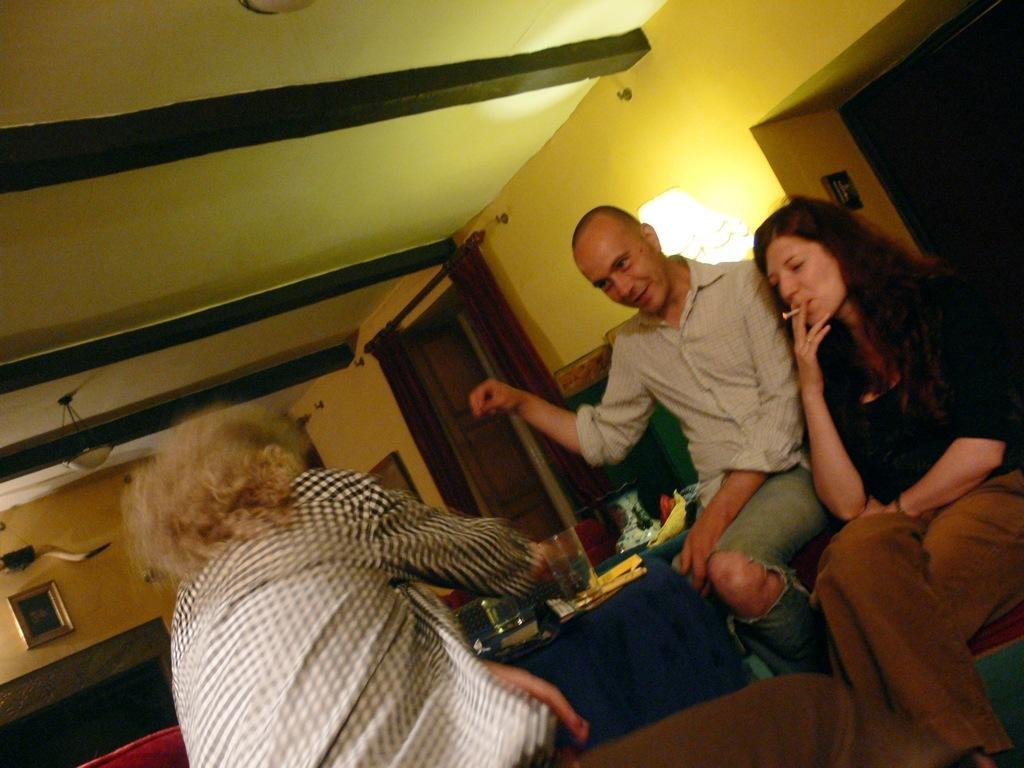Please provide a concise description of this image. In the foreground I can see three persons are sitting on sofas and one person is holding a cigar in hand. In the background I can see a table, glasses, plates, cushions, wall, light, door, photo frames and a rooftop. This image is taken may be in a room. 